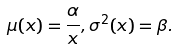Convert formula to latex. <formula><loc_0><loc_0><loc_500><loc_500>\mu ( x ) = \frac { \alpha } { x } , \sigma ^ { 2 } ( x ) = \beta .</formula> 